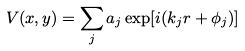<formula> <loc_0><loc_0><loc_500><loc_500>V ( x , y ) = \sum _ { j } a _ { j } \exp [ i ( { k _ { j } r } + \phi _ { j } ) ]</formula> 